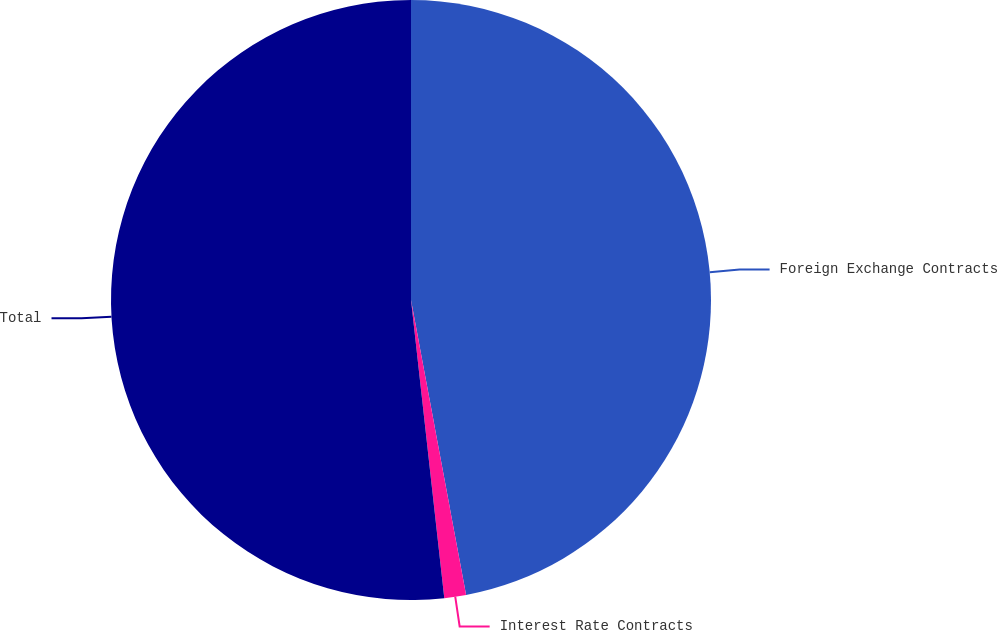<chart> <loc_0><loc_0><loc_500><loc_500><pie_chart><fcel>Foreign Exchange Contracts<fcel>Interest Rate Contracts<fcel>Total<nl><fcel>47.06%<fcel>1.17%<fcel>51.77%<nl></chart> 